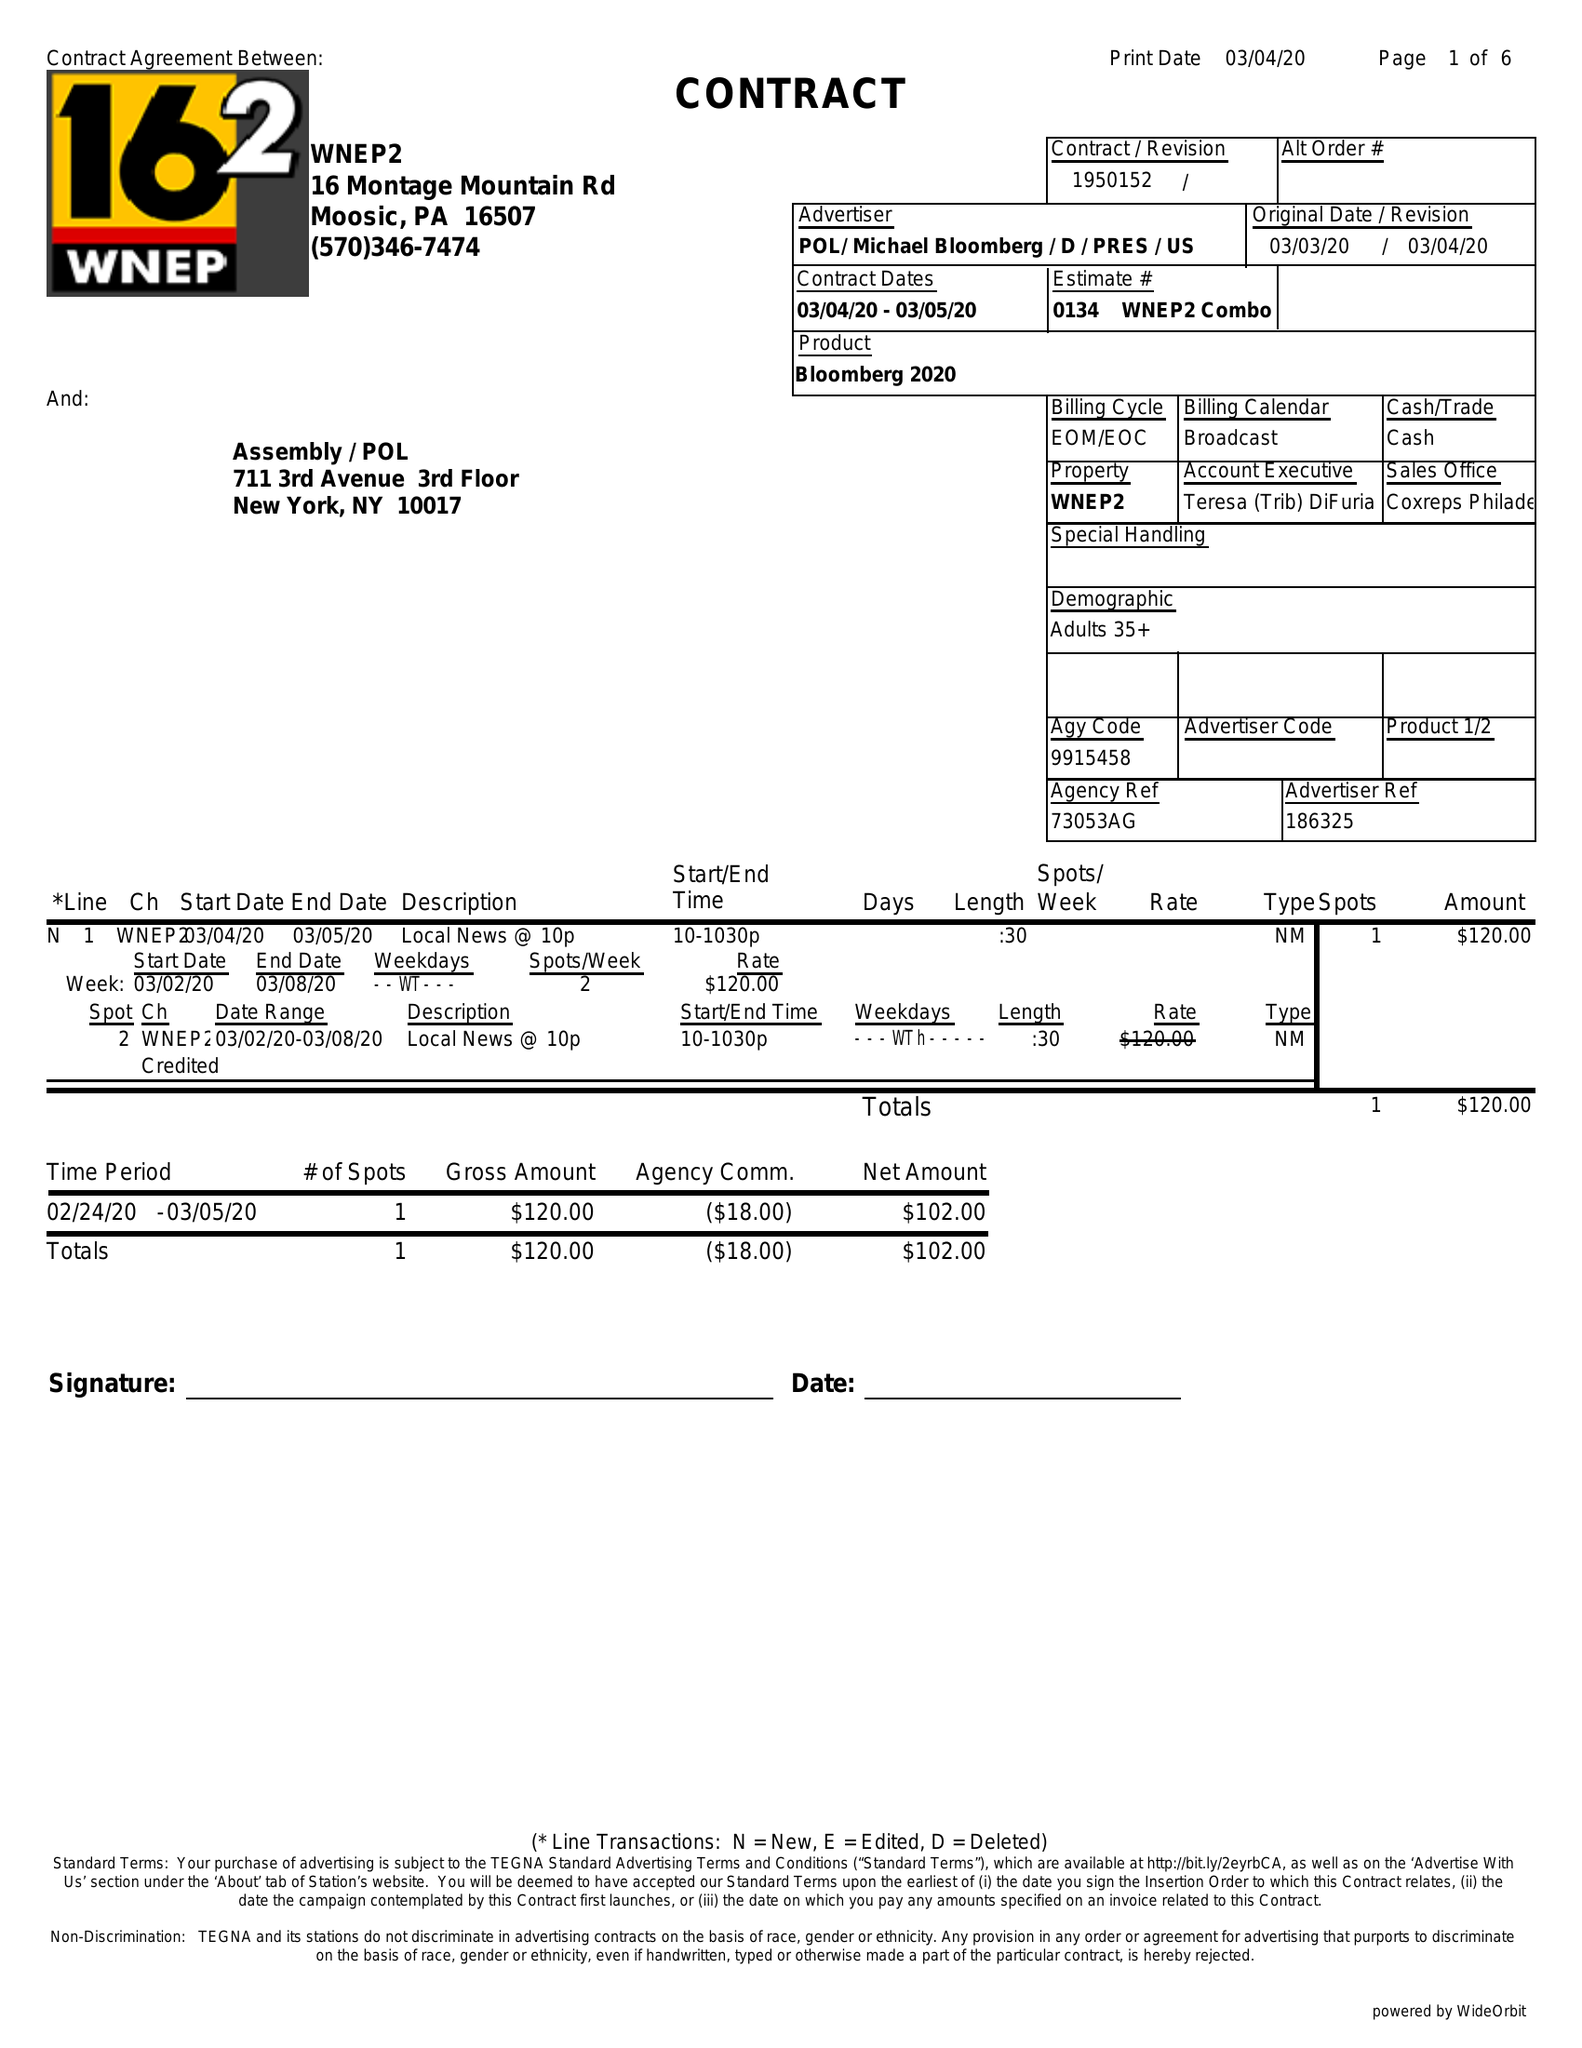What is the value for the advertiser?
Answer the question using a single word or phrase. POL/MICHAELBLOOMBERG/D/PRES/US 